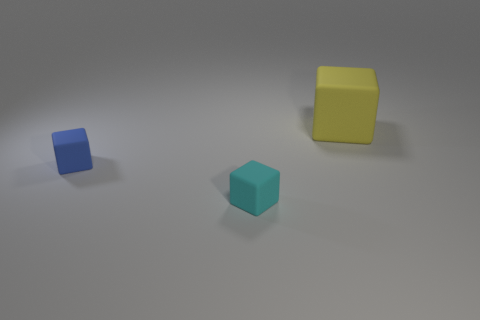Subtract all big yellow cubes. How many cubes are left? 2 Add 1 small blue matte objects. How many objects exist? 4 Subtract 0 green balls. How many objects are left? 3 Subtract all blue blocks. Subtract all cyan spheres. How many blocks are left? 2 Subtract all small cyan shiny objects. Subtract all blue matte blocks. How many objects are left? 2 Add 1 tiny blocks. How many tiny blocks are left? 3 Add 2 blue rubber objects. How many blue rubber objects exist? 3 